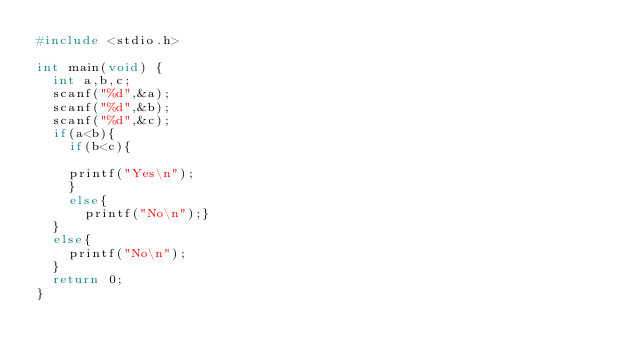<code> <loc_0><loc_0><loc_500><loc_500><_C_>#include <stdio.h>

int main(void) {
	int a,b,c;
	scanf("%d",&a);
	scanf("%d",&b);
	scanf("%d",&c);
	if(a<b){
		if(b<c){
	
		printf("Yes\n");
		}
		else{
			printf("No\n");}
	}
	else{
		printf("No\n");
	}
	return 0;
}</code> 